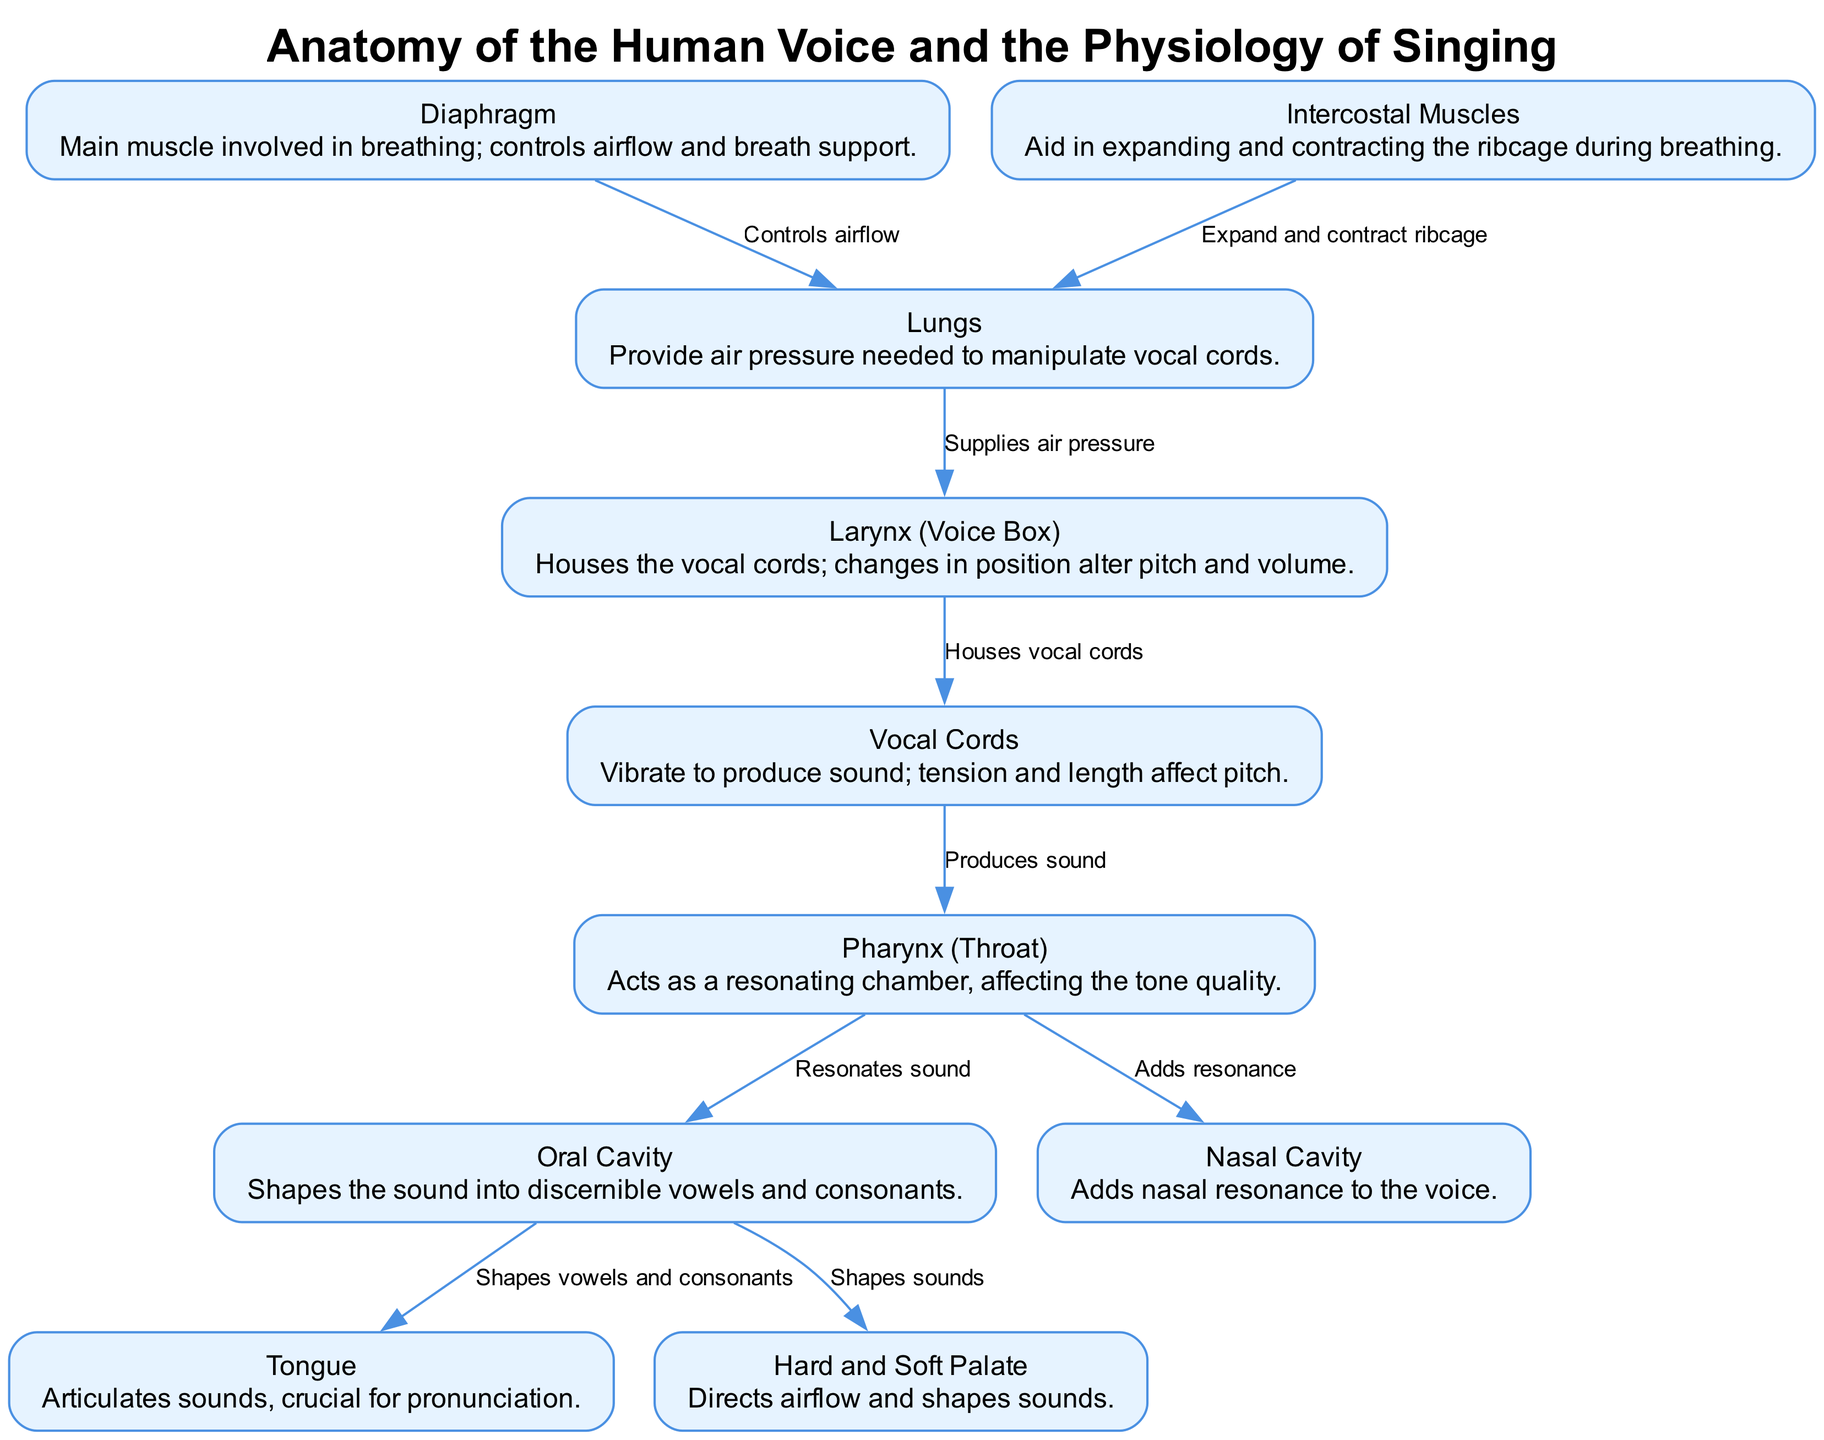What is the main muscle involved in breathing? The diagram identifies the diaphragm as the main muscle involved in breathing. This identification is found in the label and description for the diaphragm node.
Answer: Diaphragm How do the lungs contribute to the process of singing? According to the diagram, the lungs supply the air pressure needed to manipulate the vocal cords. This relationship is shown through the edge connecting the lungs to the larynx.
Answer: Supplies air pressure What part houses the vocal cords? The diagram illustrates that the larynx, also known as the voice box, houses the vocal cords, as indicated in the label of the larynx node.
Answer: Larynx Which anatomical part adds nasal resonance to the voice? The diagram specifies that the nasal cavity is responsible for adding nasal resonance to the voice, as described in the nasal cavity's information.
Answer: Nasal Cavity How many main components are directly involved in shaping sounds? By counting the relevant nodes on the diagram, we see that three main components—oral cavity, tongue, and hard and soft palate—are involved in shaping sounds. This count includes all three nodes that affect sound production.
Answer: Three What is the role of the intercostal muscles in the singing process? The diagram describes the intercostal muscles as aiding in expanding and contracting the ribcage during breathing, which is crucial for breath support in singing. This is shown by the edge pointing to the lungs.
Answer: Expand and contract ribcage Which two parts are responsible for producing sound? The diagram indicates that the vocal cords and pharynx are responsible for producing sound. The vocal cords vibrate to create sound, while the pharynx resonates it, as connected in the edges leading from the vocal cords to the pharynx.
Answer: Vocal cords and pharynx What structural component affects pitch and volume by changing its position? The diagram states that the larynx changes position to alter pitch and volume, as detailed in the larynx node's description.
Answer: Larynx 